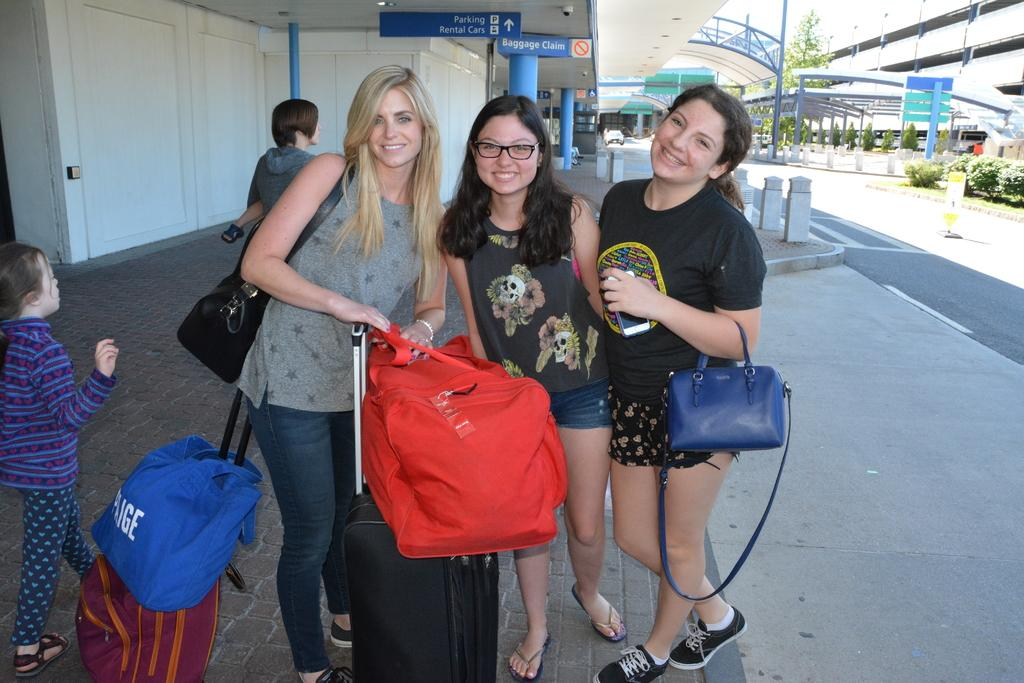What is the main subject in the center of the image? There are ladies in the center of the image. What can be seen at the bottom side of the image? There is luggage at the bottom side of the image. What type of vegetation is on the right side of the image? There are plants on the right side of the image. How many sheep can be seen grazing on the plants in the image? There are no sheep present in the image; it features ladies, luggage, and plants. What type of hook can be seen in the image? There is no hook present in the image. 